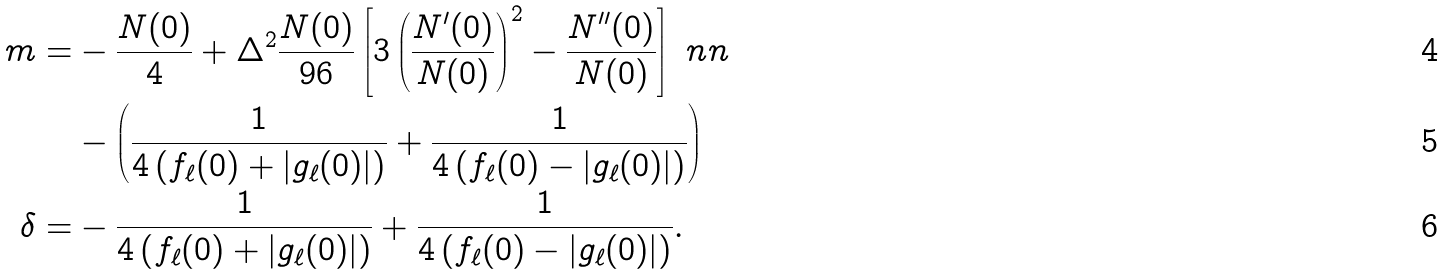<formula> <loc_0><loc_0><loc_500><loc_500>m = & - \frac { N ( 0 ) } { 4 } + \Delta ^ { 2 } \frac { N ( 0 ) } { 9 6 } \left [ 3 \left ( \frac { N ^ { \prime } ( 0 ) } { N ( 0 ) } \right ) ^ { 2 } - \frac { N ^ { \prime \prime } ( 0 ) } { N ( 0 ) } \right ] \ n n \\ & - \left ( \frac { 1 } { 4 \left ( f _ { \ell } ( 0 ) + | g _ { \ell } ( 0 ) | \right ) } + \frac { 1 } { 4 \left ( f _ { \ell } ( 0 ) - | g _ { \ell } ( 0 ) | \right ) } \right ) \\ \delta = & - \frac { 1 } { 4 \left ( f _ { \ell } ( 0 ) + | g _ { \ell } ( 0 ) | \right ) } + \frac { 1 } { 4 \left ( f _ { \ell } ( 0 ) - | g _ { \ell } ( 0 ) | \right ) } .</formula> 